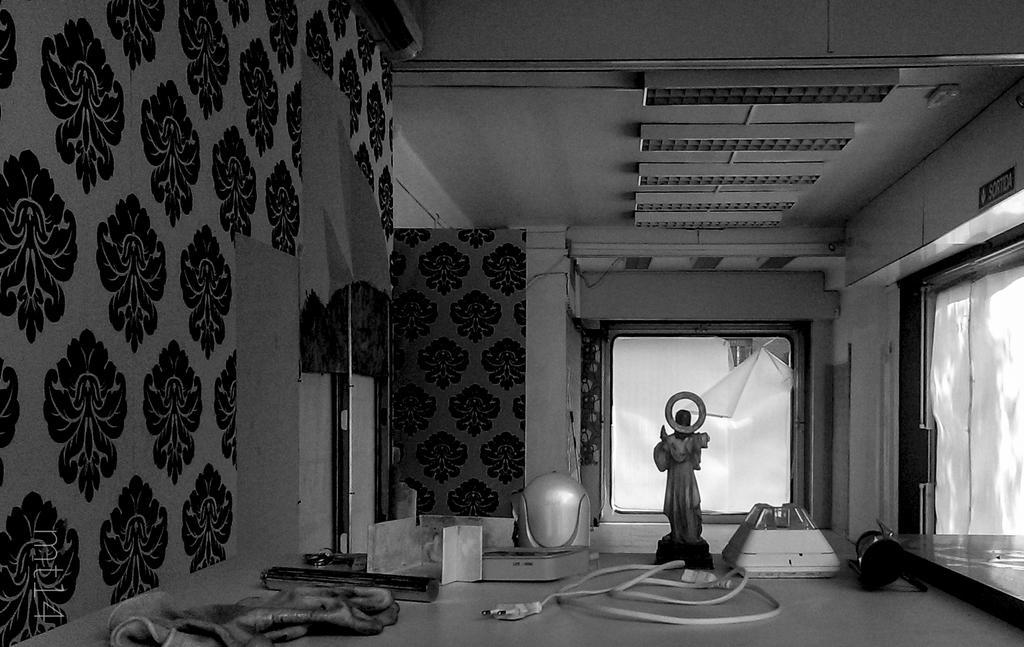Can you describe this image briefly? In this image we can see the inner view of a room and we can see the walls and there are some objects like figurine, cable wires and some other things. We can see the windows and at the top there is a ceiling with lights. 